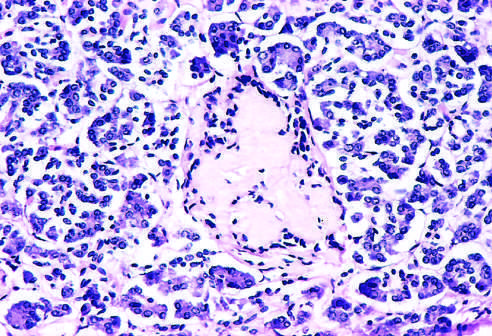s the tan-colored, encapsulated small tumor noted at earlier observations?
Answer the question using a single word or phrase. No 